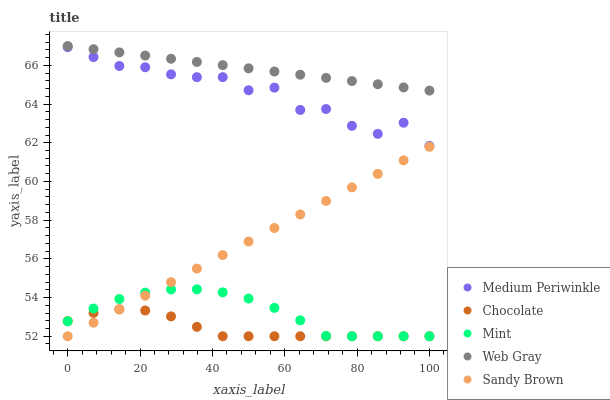Does Chocolate have the minimum area under the curve?
Answer yes or no. Yes. Does Web Gray have the maximum area under the curve?
Answer yes or no. Yes. Does Medium Periwinkle have the minimum area under the curve?
Answer yes or no. No. Does Medium Periwinkle have the maximum area under the curve?
Answer yes or no. No. Is Sandy Brown the smoothest?
Answer yes or no. Yes. Is Medium Periwinkle the roughest?
Answer yes or no. Yes. Is Web Gray the smoothest?
Answer yes or no. No. Is Web Gray the roughest?
Answer yes or no. No. Does Mint have the lowest value?
Answer yes or no. Yes. Does Medium Periwinkle have the lowest value?
Answer yes or no. No. Does Web Gray have the highest value?
Answer yes or no. Yes. Does Medium Periwinkle have the highest value?
Answer yes or no. No. Is Mint less than Web Gray?
Answer yes or no. Yes. Is Medium Periwinkle greater than Sandy Brown?
Answer yes or no. Yes. Does Mint intersect Chocolate?
Answer yes or no. Yes. Is Mint less than Chocolate?
Answer yes or no. No. Is Mint greater than Chocolate?
Answer yes or no. No. Does Mint intersect Web Gray?
Answer yes or no. No. 